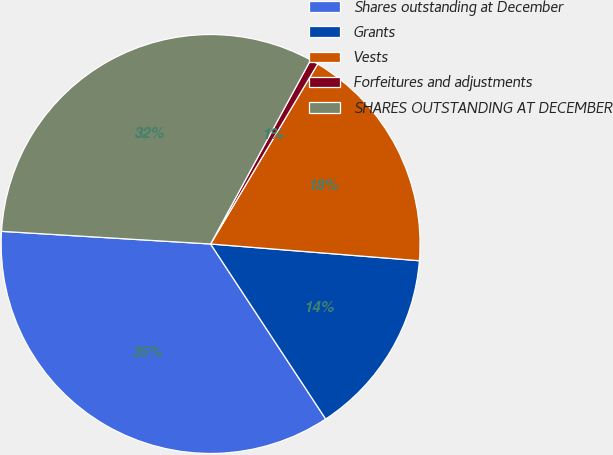Convert chart to OTSL. <chart><loc_0><loc_0><loc_500><loc_500><pie_chart><fcel>Shares outstanding at December<fcel>Grants<fcel>Vests<fcel>Forfeitures and adjustments<fcel>SHARES OUTSTANDING AT DECEMBER<nl><fcel>35.22%<fcel>14.47%<fcel>17.73%<fcel>0.62%<fcel>31.96%<nl></chart> 